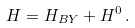<formula> <loc_0><loc_0><loc_500><loc_500>H = H _ { B Y } + H ^ { 0 } \, .</formula> 